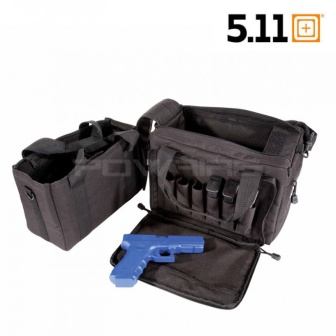Could this bag be suitable for everyday use, such as commuting or general travel? Absolutely, the tactical bag's sturdy build and multiple compartments make it ideal for commuting or general travel. Its ample storage space is perfect for organizing everyday items like laptops, books, chargers, and personal belongings, while the padded straps offer comfort for prolonged carrying. The discreet appearance ensures it blends seamlessly into an urban environment or workplace. 